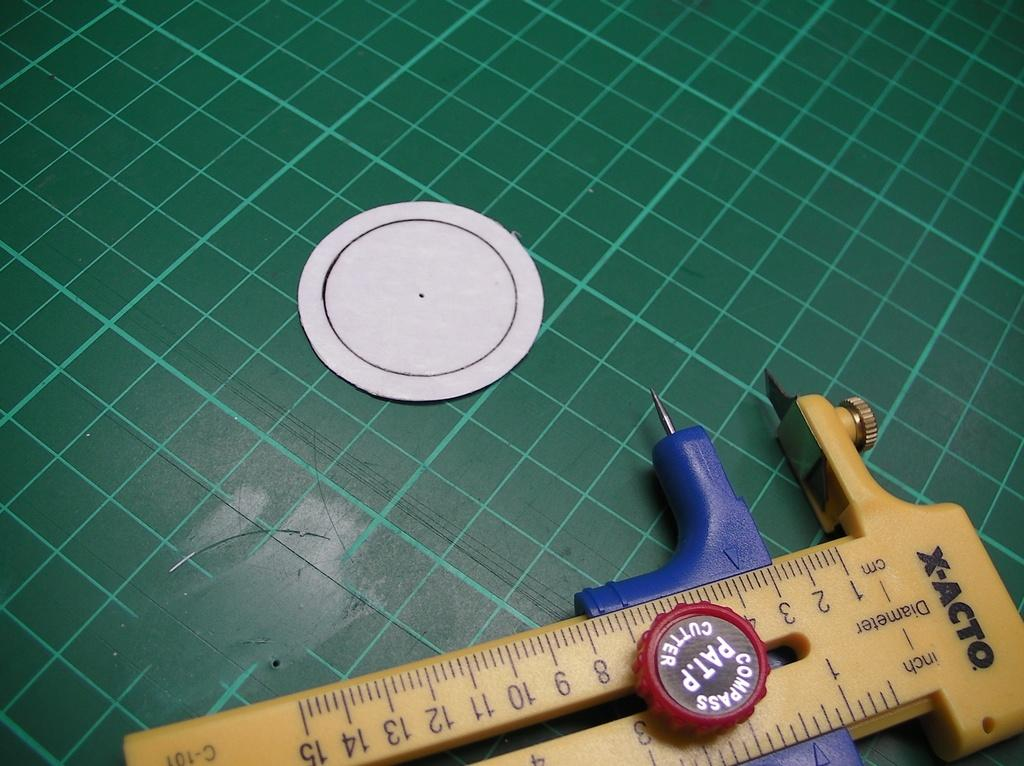<image>
Create a compact narrative representing the image presented. An X-Acto cutter lists diameters in both inches and centimeters. 